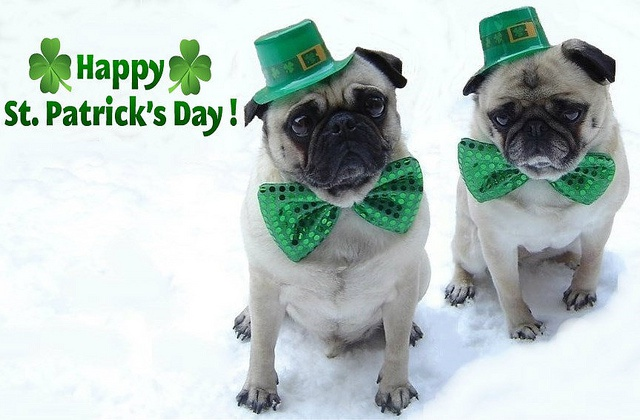Describe the objects in this image and their specific colors. I can see dog in white, darkgray, black, gray, and lightgray tones, dog in white, darkgray, gray, black, and lightgray tones, tie in white, darkgreen, green, and black tones, and tie in white, green, darkgreen, and teal tones in this image. 